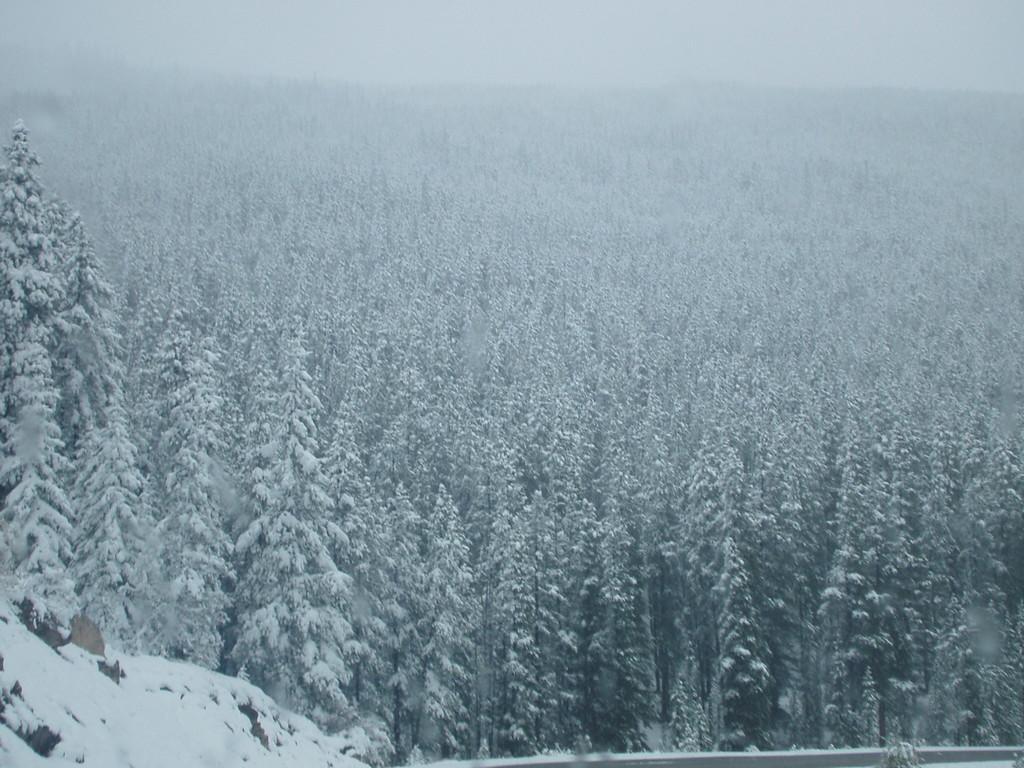Describe this image in one or two sentences. This is an outside view. Here I can see many trees covered with the snow. 